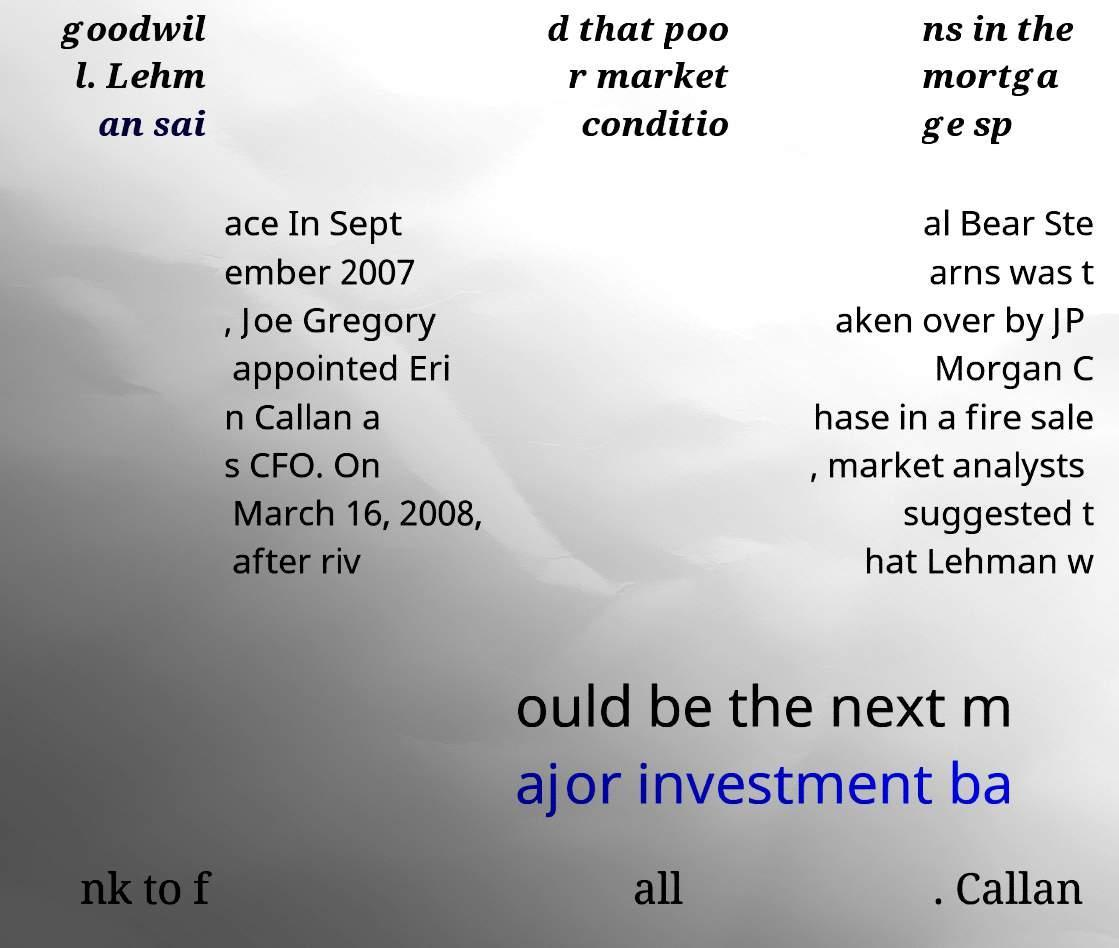Please read and relay the text visible in this image. What does it say? goodwil l. Lehm an sai d that poo r market conditio ns in the mortga ge sp ace In Sept ember 2007 , Joe Gregory appointed Eri n Callan a s CFO. On March 16, 2008, after riv al Bear Ste arns was t aken over by JP Morgan C hase in a fire sale , market analysts suggested t hat Lehman w ould be the next m ajor investment ba nk to f all . Callan 